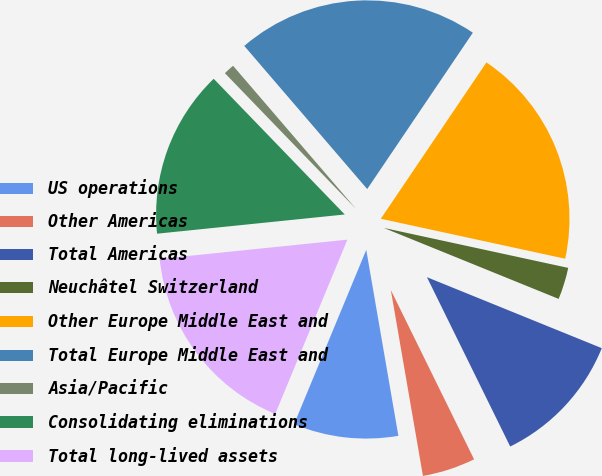Convert chart. <chart><loc_0><loc_0><loc_500><loc_500><pie_chart><fcel>US operations<fcel>Other Americas<fcel>Total Americas<fcel>Neuchâtel Switzerland<fcel>Other Europe Middle East and<fcel>Total Europe Middle East and<fcel>Asia/Pacific<fcel>Consolidating eliminations<fcel>Total long-lived assets<nl><fcel>8.97%<fcel>4.55%<fcel>11.59%<fcel>2.74%<fcel>18.94%<fcel>20.75%<fcel>0.93%<fcel>14.4%<fcel>17.13%<nl></chart> 